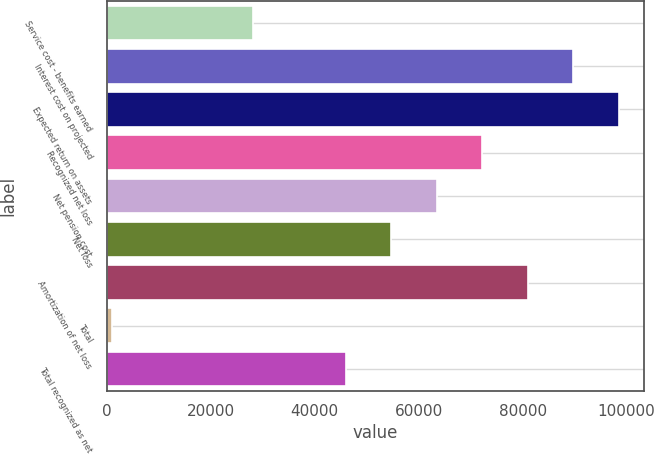Convert chart. <chart><loc_0><loc_0><loc_500><loc_500><bar_chart><fcel>Service cost - benefits earned<fcel>Interest cost on projected<fcel>Expected return on assets<fcel>Recognized net loss<fcel>Net pension cost<fcel>Net loss<fcel>Amortization of net loss<fcel>Total<fcel>Total recognized as net<nl><fcel>28194<fcel>89702<fcel>98436.2<fcel>72233.6<fcel>63499.4<fcel>54765.2<fcel>80967.8<fcel>1041<fcel>46031<nl></chart> 